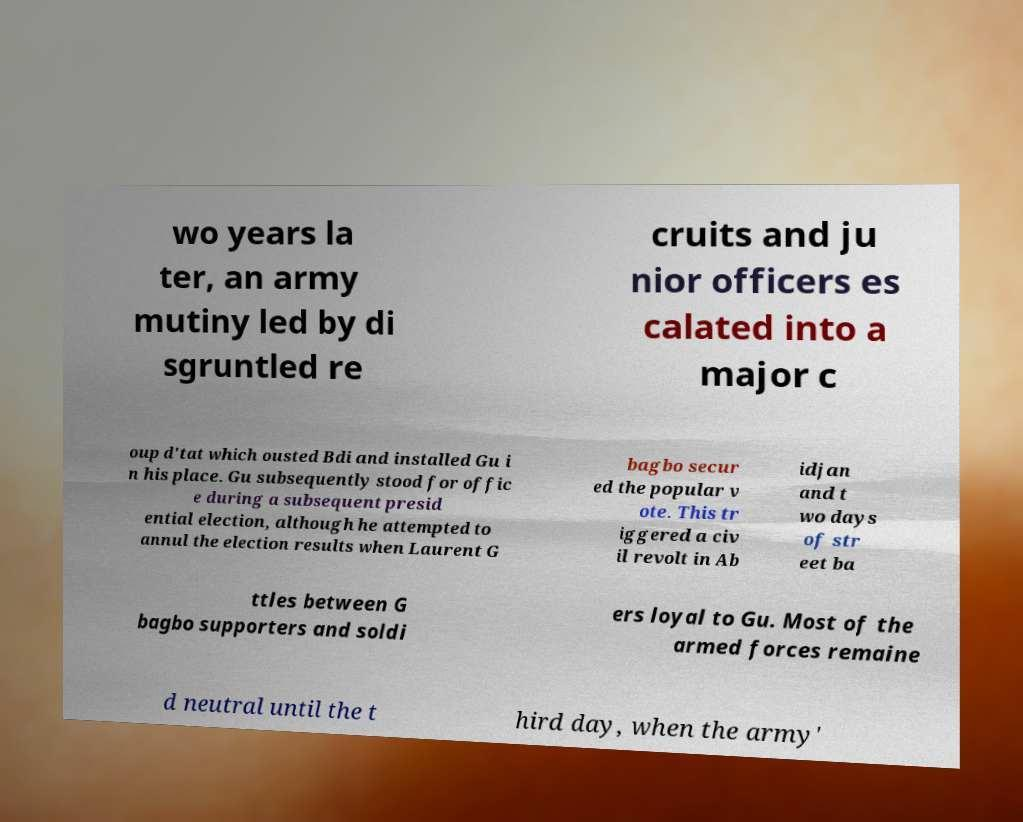What messages or text are displayed in this image? I need them in a readable, typed format. wo years la ter, an army mutiny led by di sgruntled re cruits and ju nior officers es calated into a major c oup d'tat which ousted Bdi and installed Gu i n his place. Gu subsequently stood for offic e during a subsequent presid ential election, although he attempted to annul the election results when Laurent G bagbo secur ed the popular v ote. This tr iggered a civ il revolt in Ab idjan and t wo days of str eet ba ttles between G bagbo supporters and soldi ers loyal to Gu. Most of the armed forces remaine d neutral until the t hird day, when the army' 